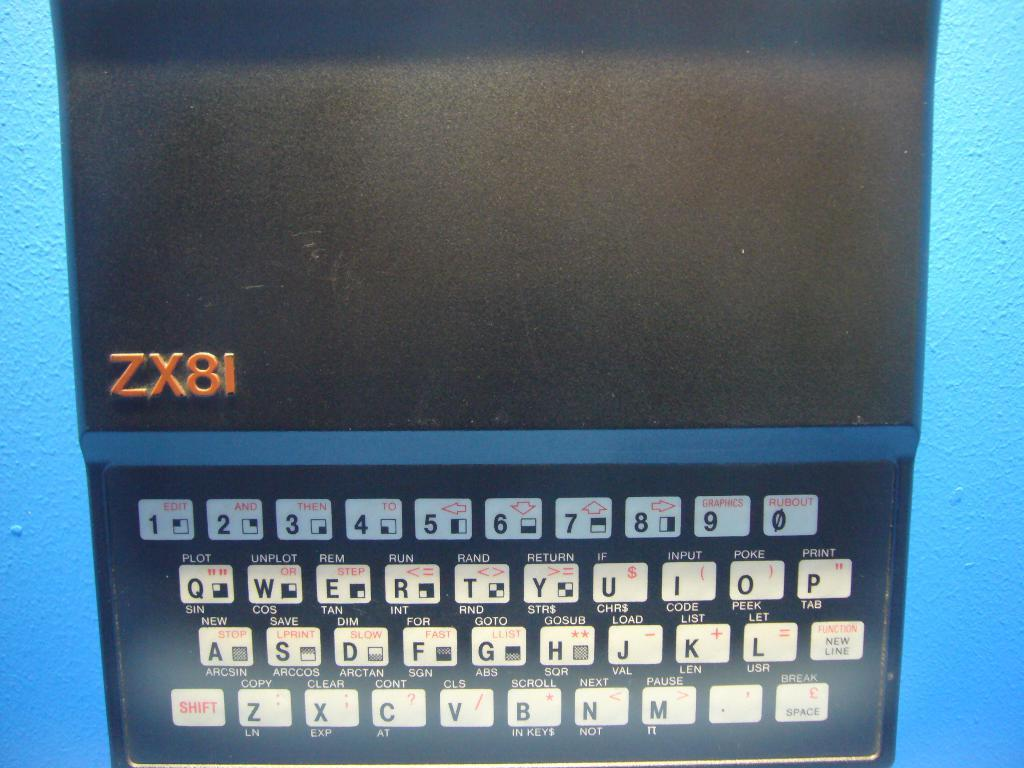<image>
Offer a succinct explanation of the picture presented. a computer keyboard with ZX8I written above the keys. 